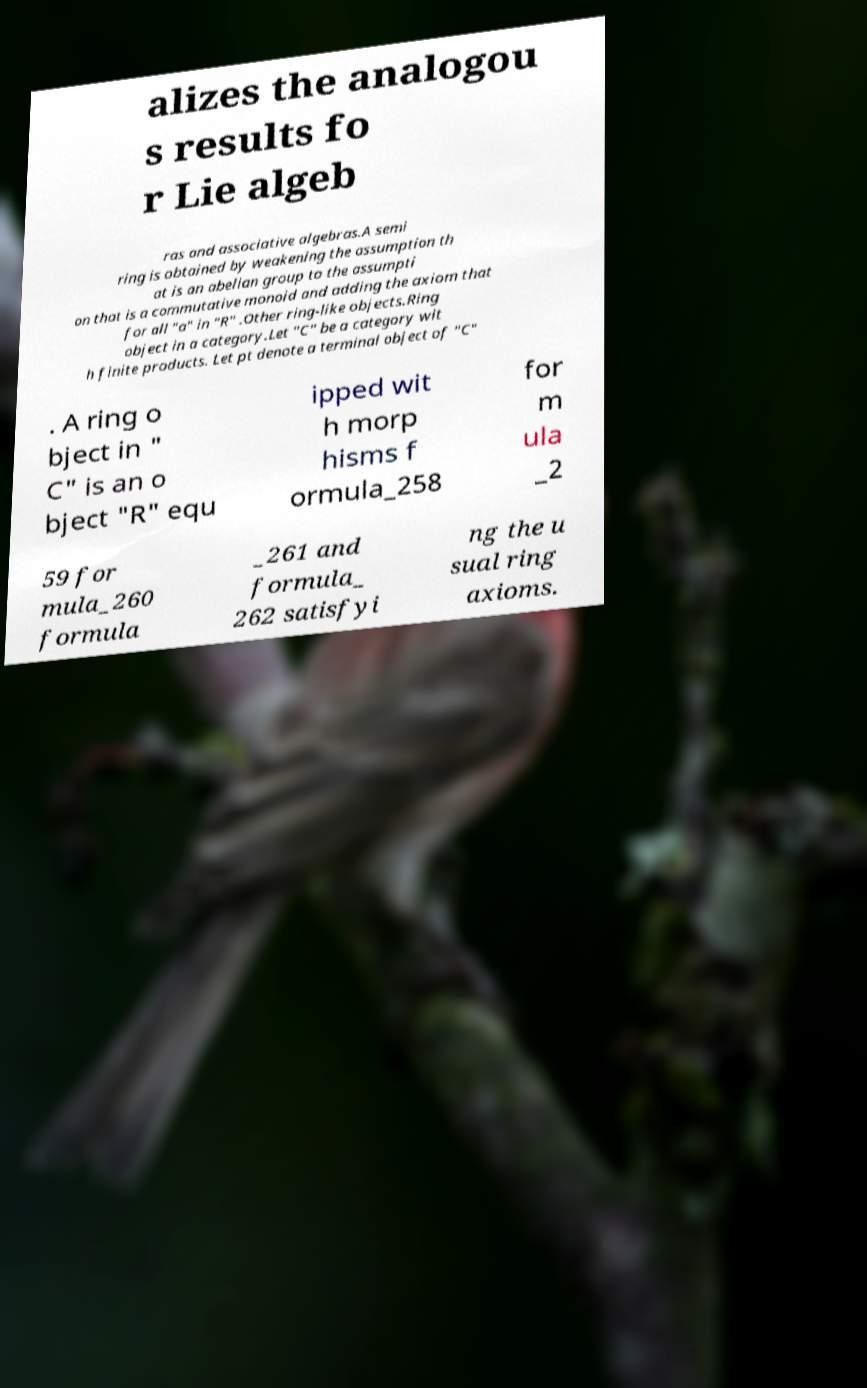For documentation purposes, I need the text within this image transcribed. Could you provide that? alizes the analogou s results fo r Lie algeb ras and associative algebras.A semi ring is obtained by weakening the assumption th at is an abelian group to the assumpti on that is a commutative monoid and adding the axiom that for all "a" in "R" .Other ring-like objects.Ring object in a category.Let "C" be a category wit h finite products. Let pt denote a terminal object of "C" . A ring o bject in " C" is an o bject "R" equ ipped wit h morp hisms f ormula_258 for m ula _2 59 for mula_260 formula _261 and formula_ 262 satisfyi ng the u sual ring axioms. 